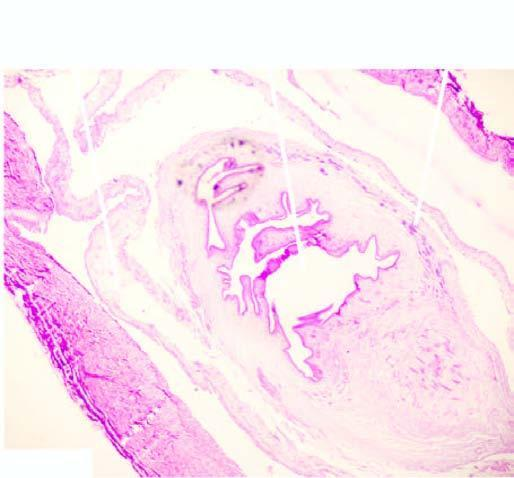what does the cyst wall show?
Answer the question using a single word or phrase. Palisade layer of histiocytes 